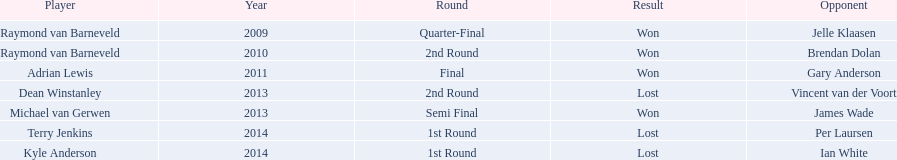What were the appellations of all the competitors? Raymond van Barneveld, Raymond van Barneveld, Adrian Lewis, Dean Winstanley, Michael van Gerwen, Terry Jenkins, Kyle Anderson. During what years was the championship conducted? 2009, 2010, 2011, 2013, 2013, 2014, 2014. From these, who competed in 2011? Adrian Lewis. 